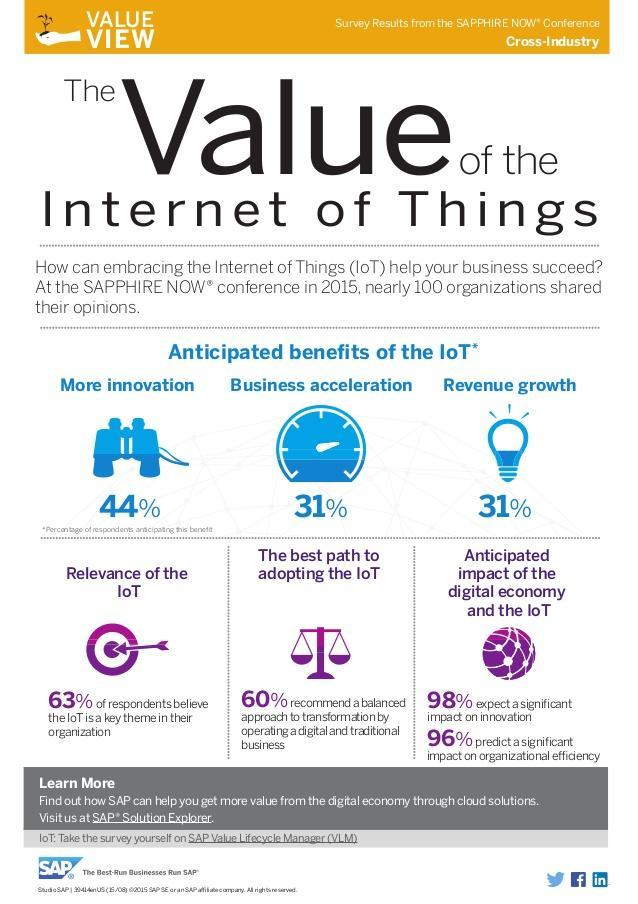What is the percentage of business feel embracing IoT will yield revenue growth and accelerate business?
Answer the question with a short phrase. 31% What percentage of believe that IoT can influence ideation, 60%, 98%, or 96%? 98% 